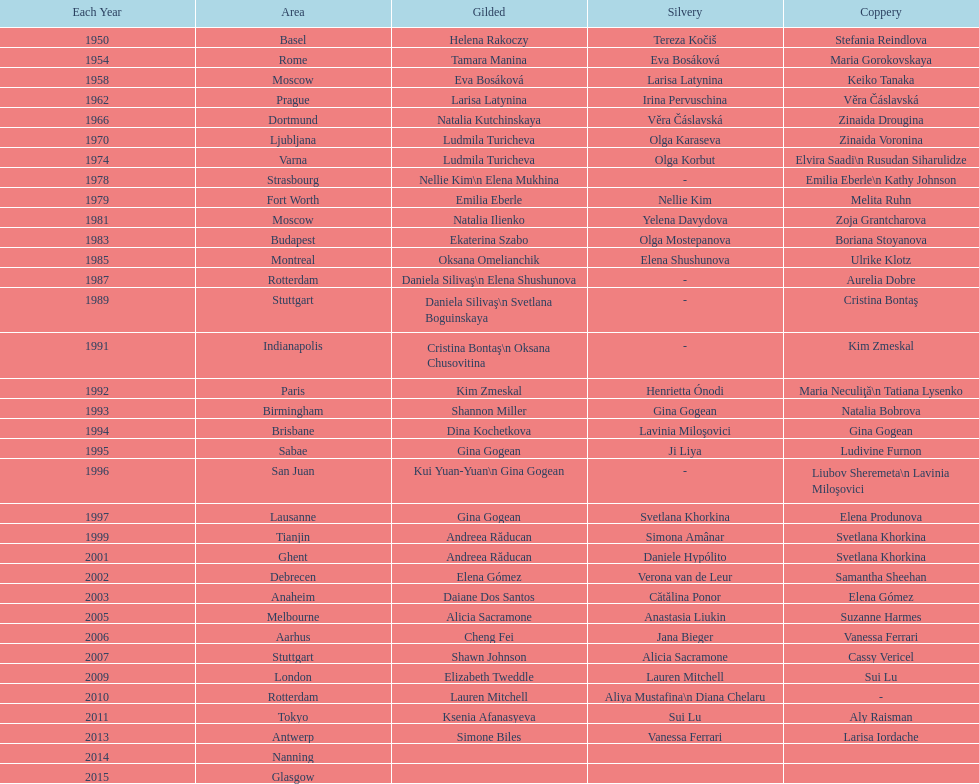What is the number of times a brazilian has won a medal? 2. 